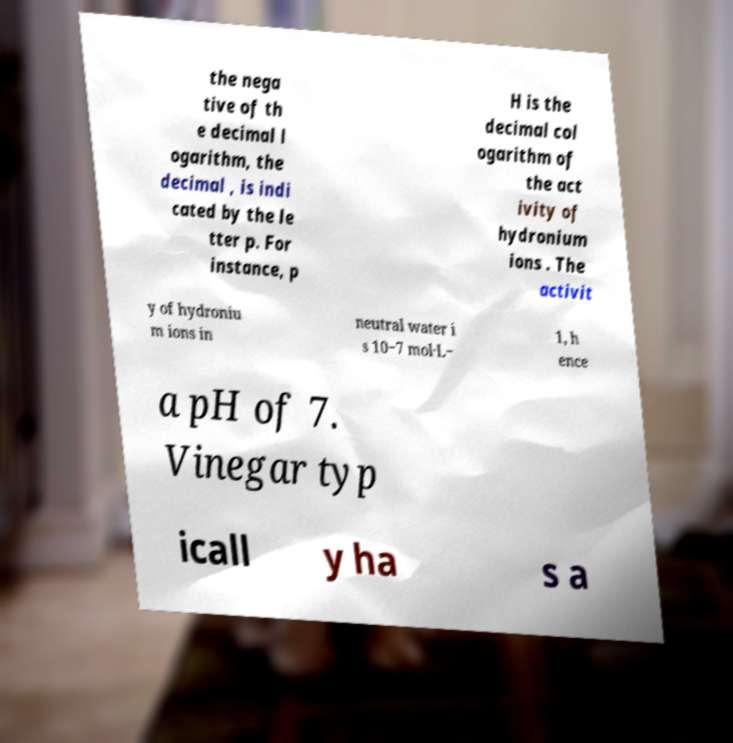Please identify and transcribe the text found in this image. the nega tive of th e decimal l ogarithm, the decimal , is indi cated by the le tter p. For instance, p H is the decimal col ogarithm of the act ivity of hydronium ions . The activit y of hydroniu m ions in neutral water i s 10−7 mol·L− 1, h ence a pH of 7. Vinegar typ icall y ha s a 